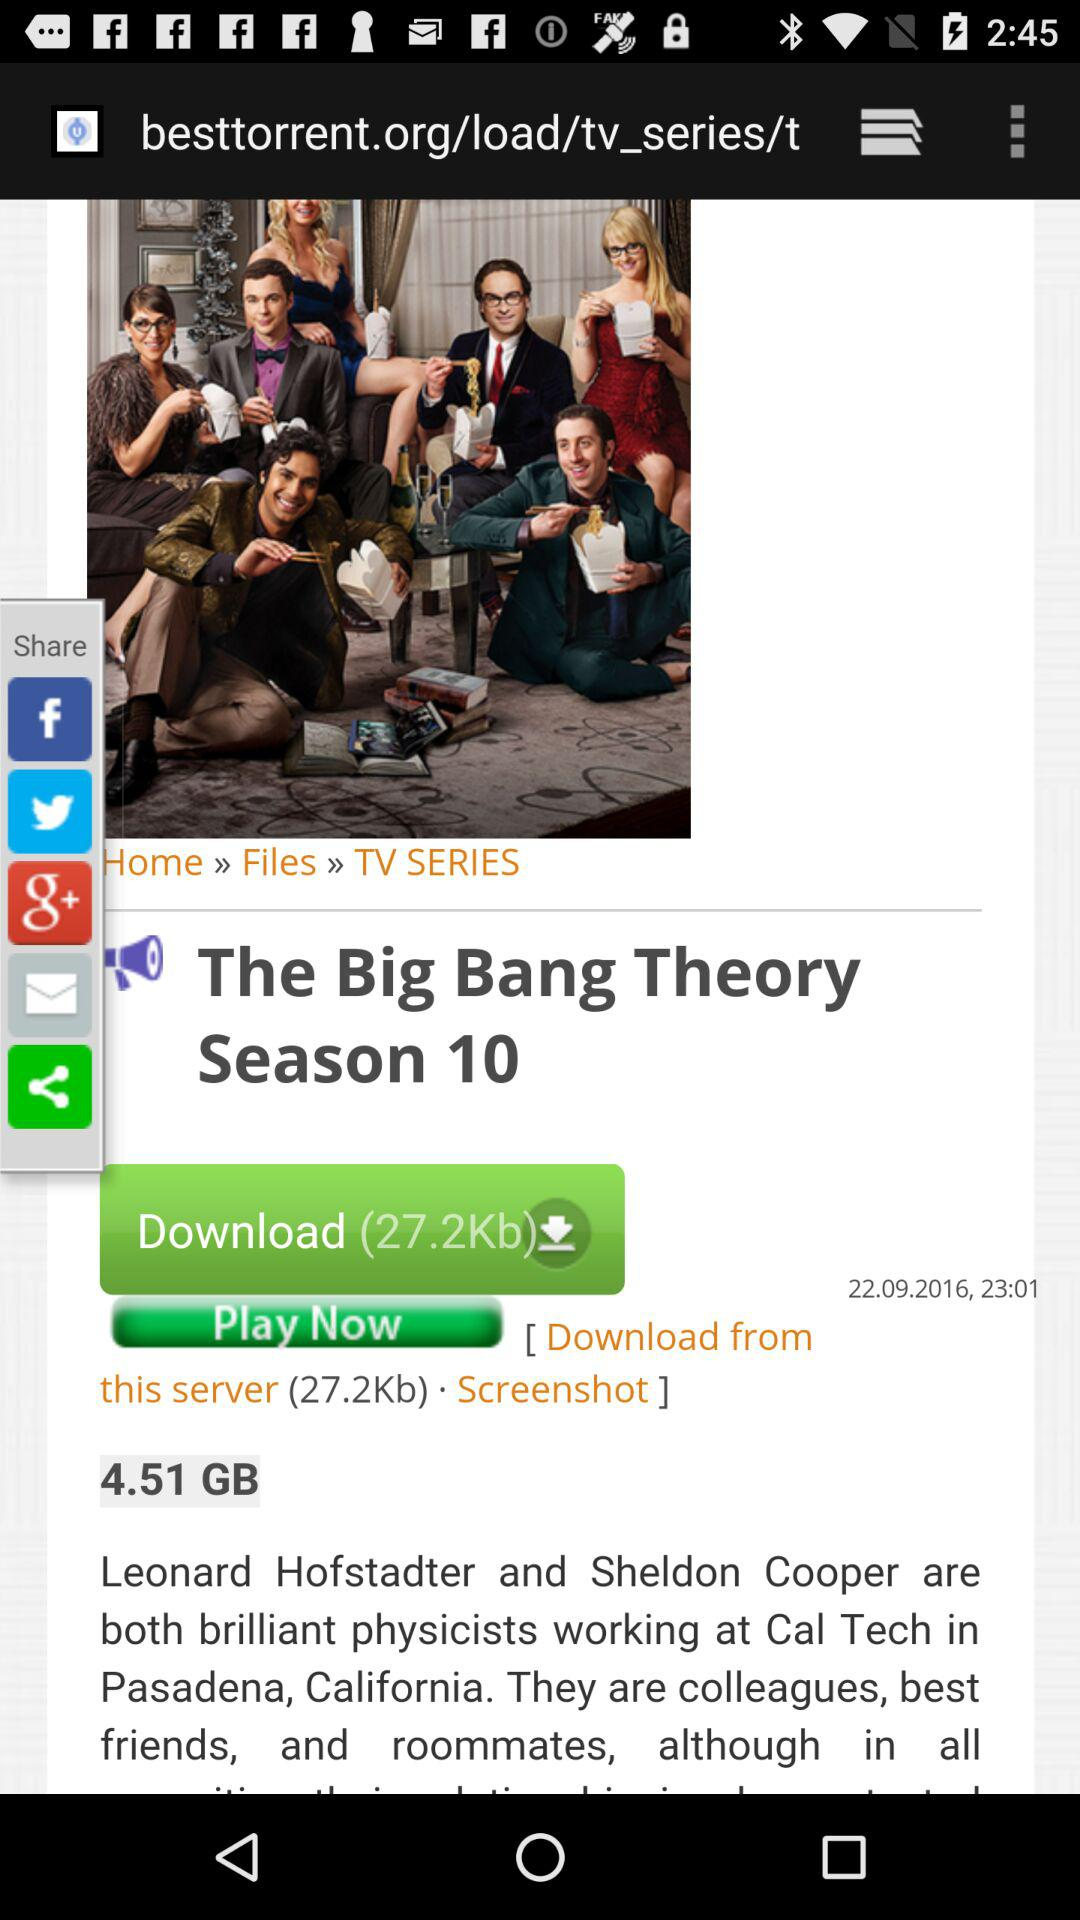What's the series name? The series name is "The Big Bang Theory". 